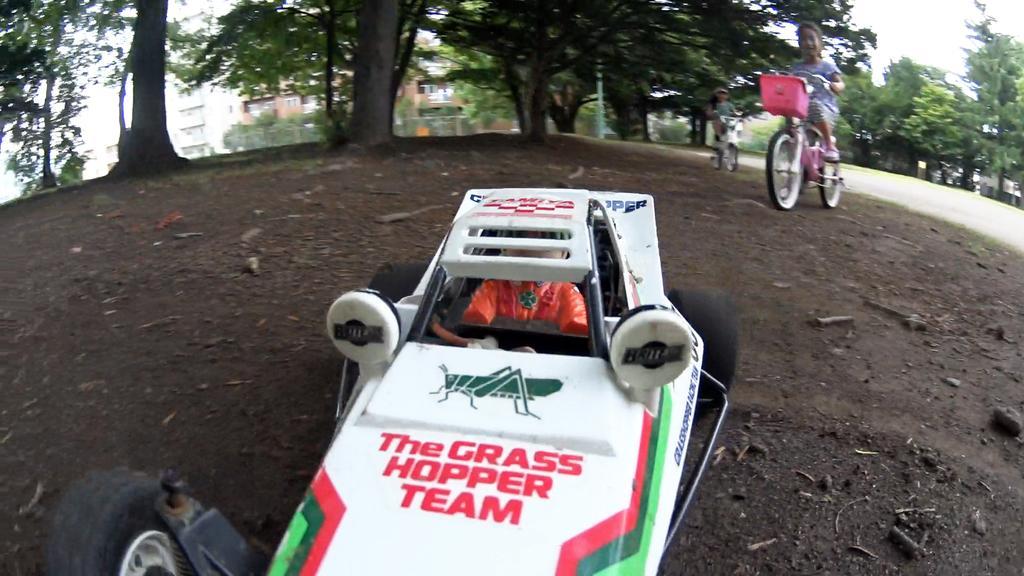How would you summarize this image in a sentence or two? This is the picture of a car which is on the floor and behind there are two kids riding the bicycles and also we can see some trees and plants. 